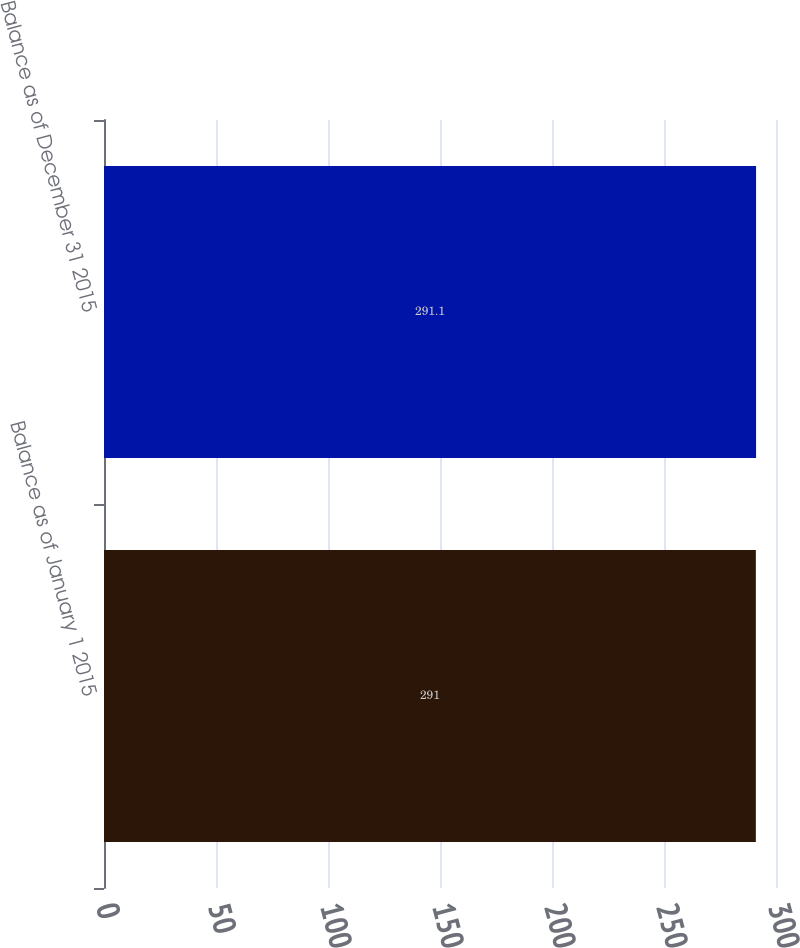<chart> <loc_0><loc_0><loc_500><loc_500><bar_chart><fcel>Balance as of January 1 2015<fcel>Balance as of December 31 2015<nl><fcel>291<fcel>291.1<nl></chart> 